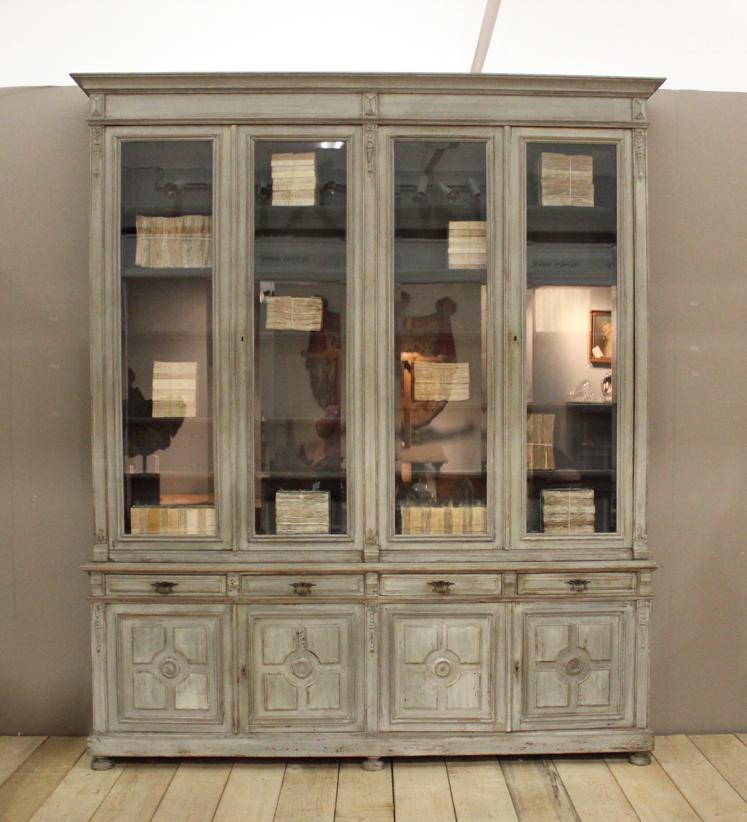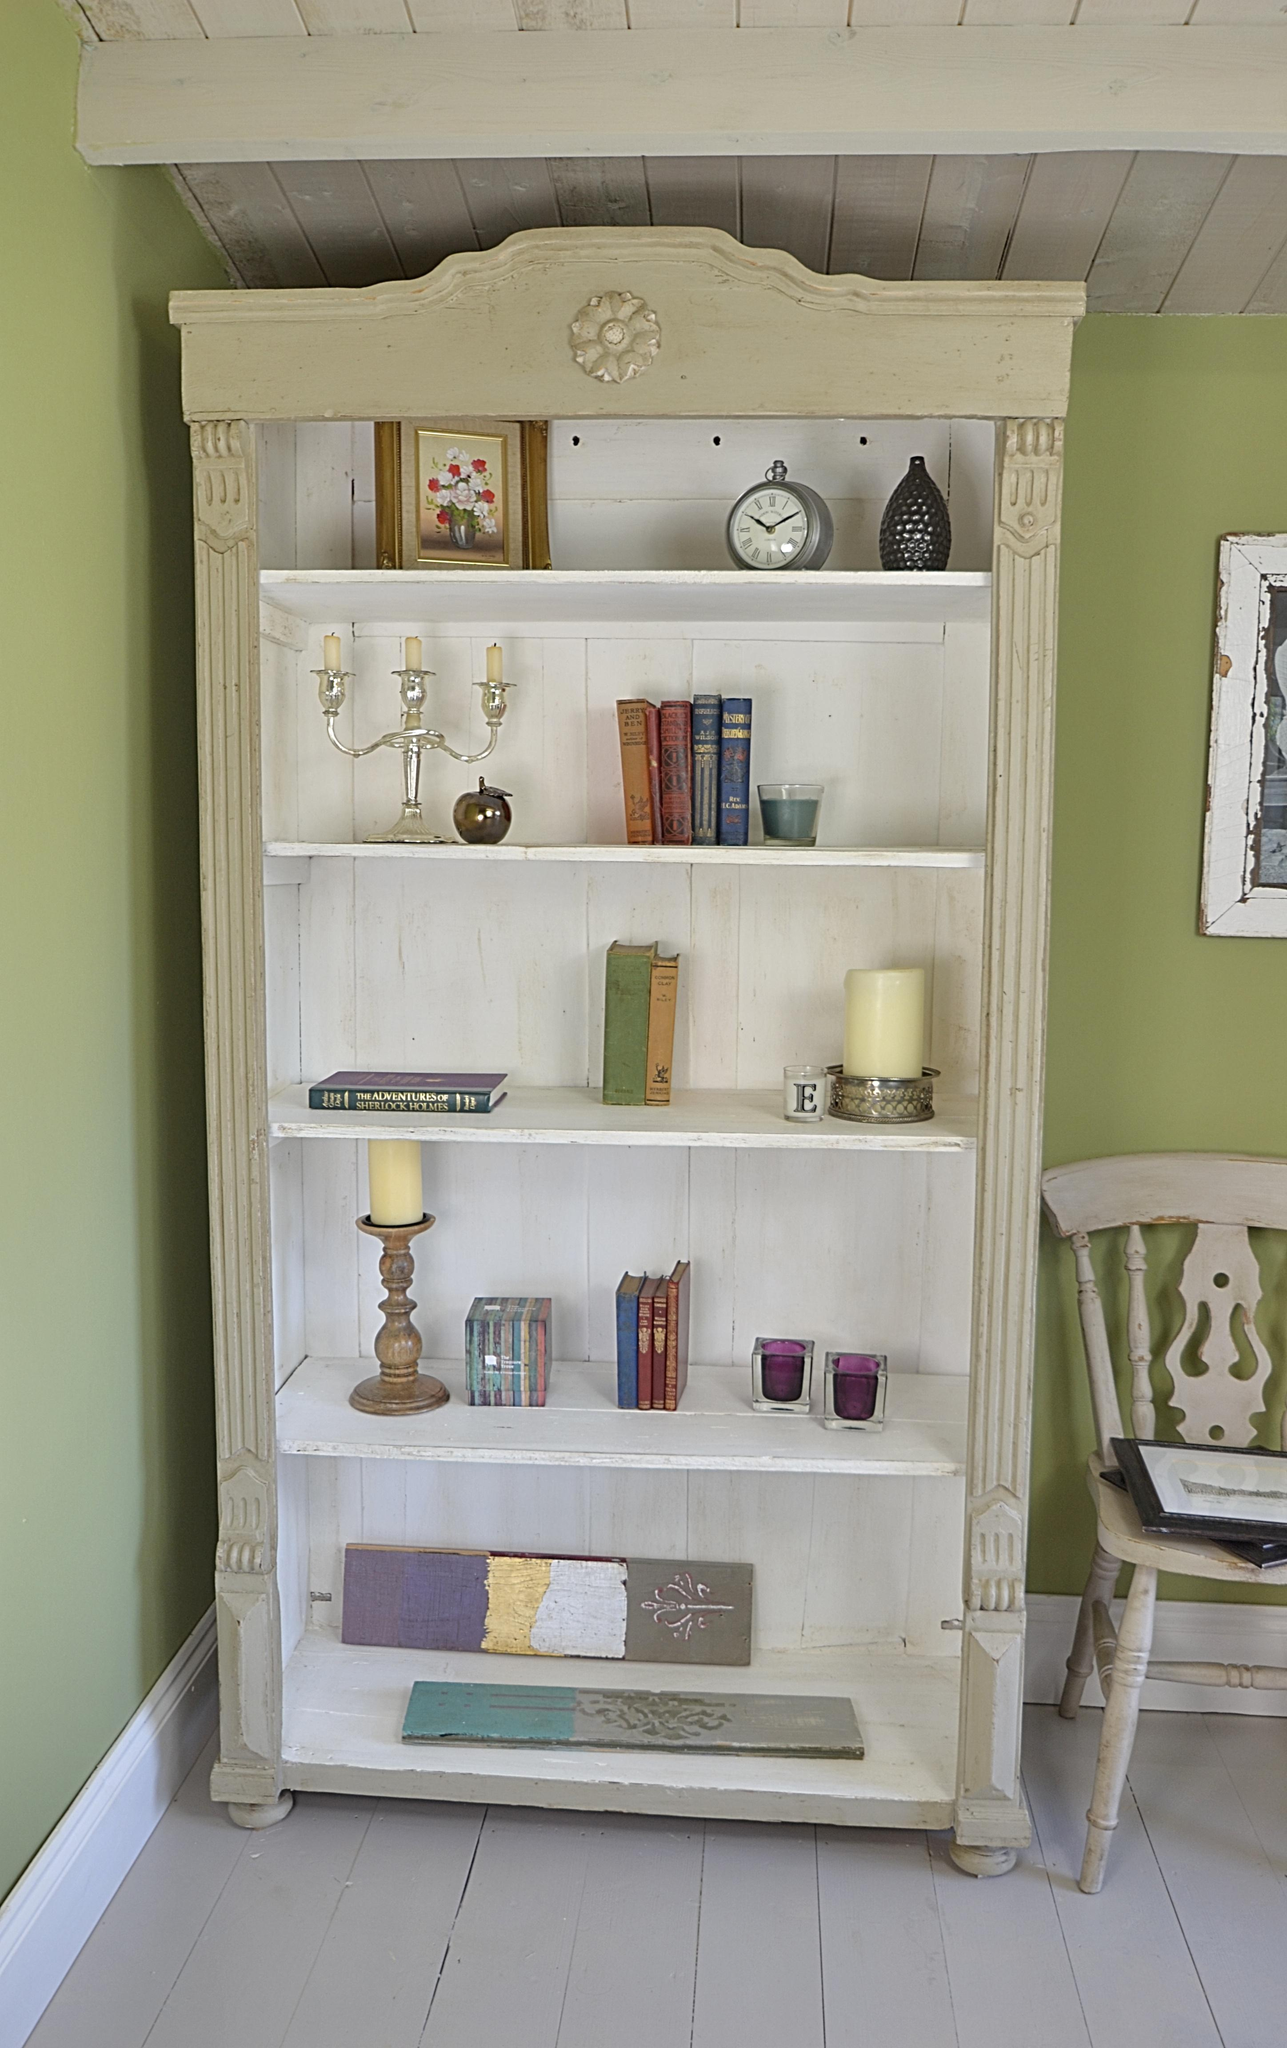The first image is the image on the left, the second image is the image on the right. For the images displayed, is the sentence "One of the cabinets has doors." factually correct? Answer yes or no. Yes. The first image is the image on the left, the second image is the image on the right. For the images shown, is this caption "At least one shelving unit is teal." true? Answer yes or no. No. 